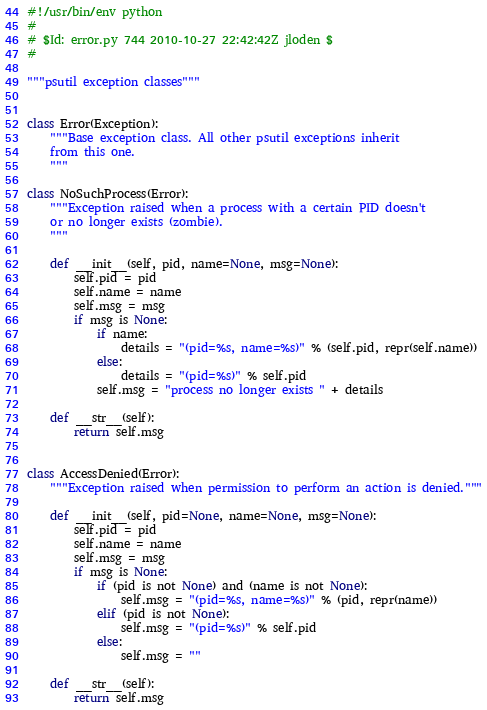<code> <loc_0><loc_0><loc_500><loc_500><_Python_>#!/usr/bin/env python
#
# $Id: error.py 744 2010-10-27 22:42:42Z jloden $
#

"""psutil exception classes"""


class Error(Exception):
    """Base exception class. All other psutil exceptions inherit
    from this one.
    """

class NoSuchProcess(Error):
    """Exception raised when a process with a certain PID doesn't
    or no longer exists (zombie).
    """

    def __init__(self, pid, name=None, msg=None):
        self.pid = pid
        self.name = name
        self.msg = msg
        if msg is None:
            if name:
                details = "(pid=%s, name=%s)" % (self.pid, repr(self.name))
            else:
                details = "(pid=%s)" % self.pid
            self.msg = "process no longer exists " + details

    def __str__(self):
        return self.msg


class AccessDenied(Error):
    """Exception raised when permission to perform an action is denied."""

    def __init__(self, pid=None, name=None, msg=None):
        self.pid = pid
        self.name = name
        self.msg = msg
        if msg is None:
            if (pid is not None) and (name is not None):
                self.msg = "(pid=%s, name=%s)" % (pid, repr(name))
            elif (pid is not None):
                self.msg = "(pid=%s)" % self.pid
            else:
                self.msg = ""

    def __str__(self):
        return self.msg

</code> 